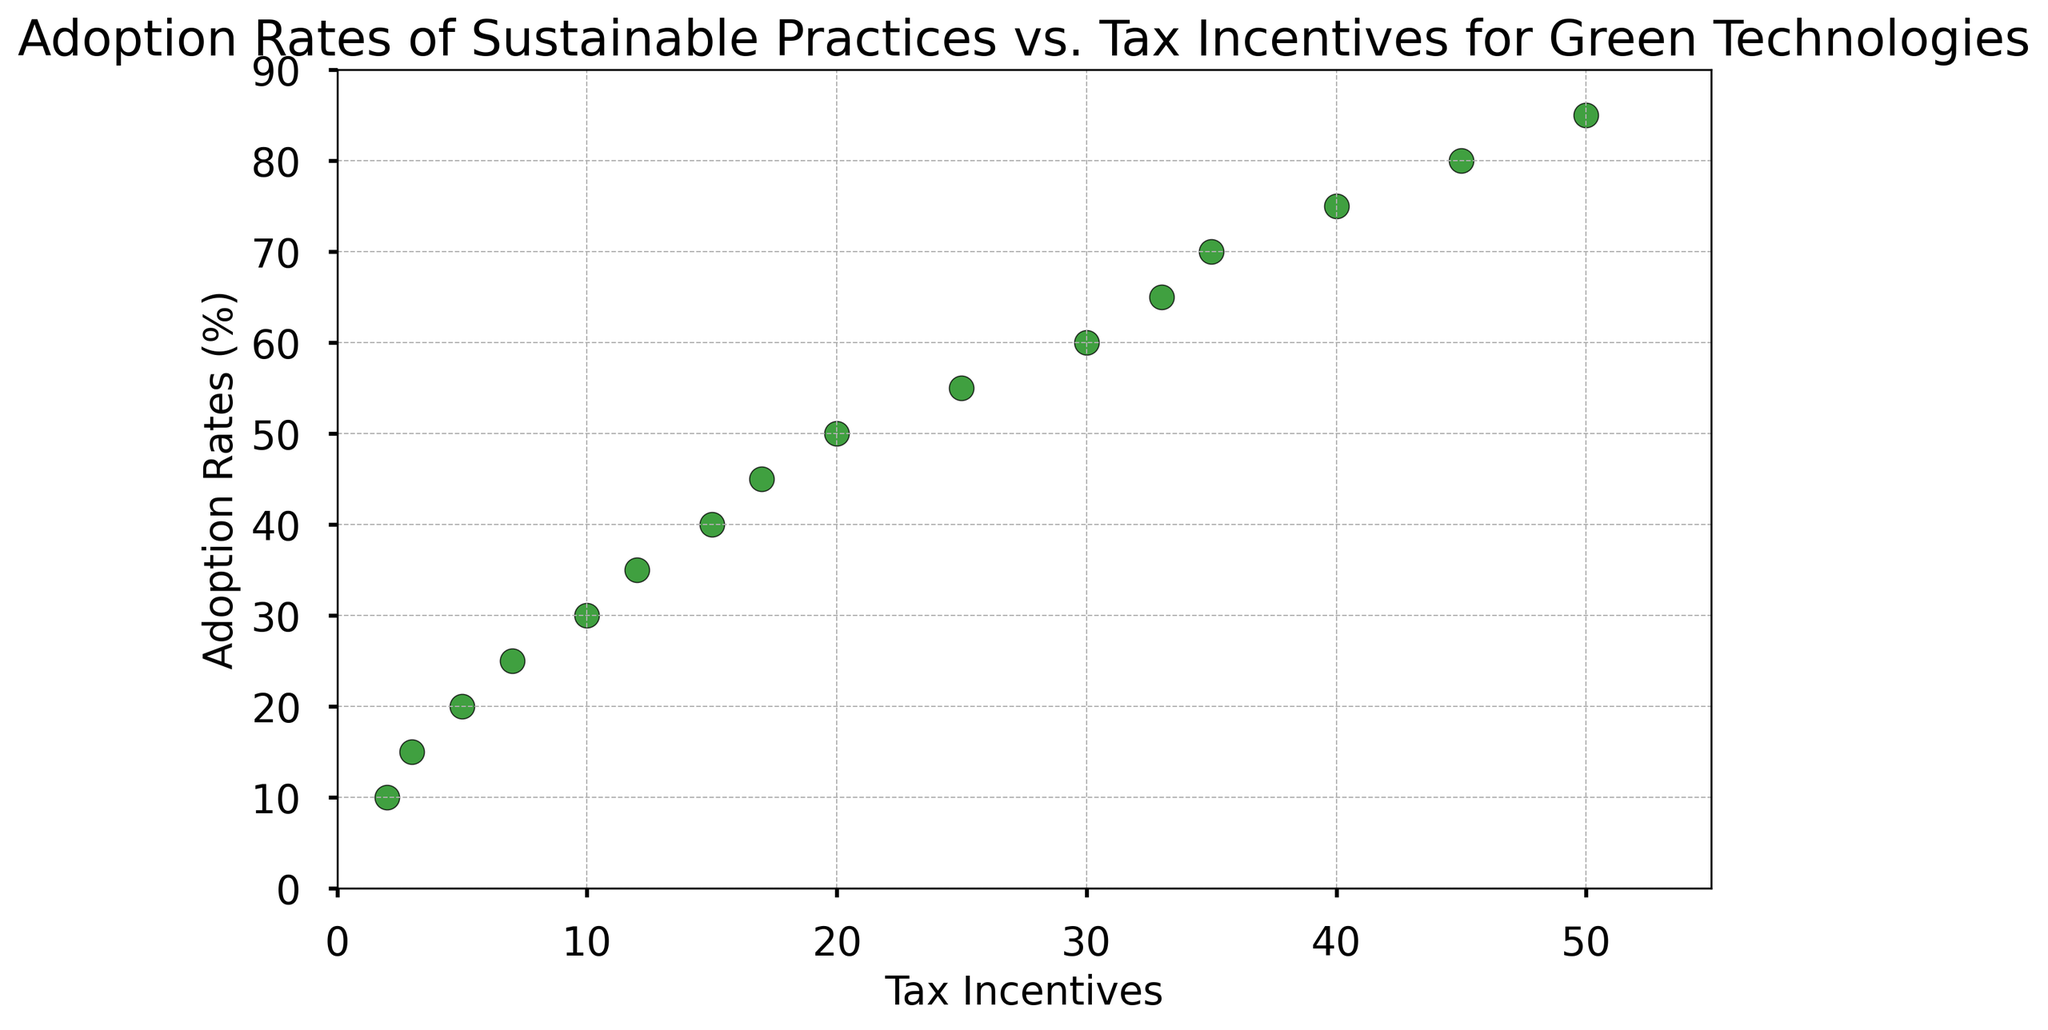What is the adoption rate of sustainable practices when tax incentives are at their maximum value? The maximum value of tax incentives in the plot is 50. At this point, the corresponding adoption rate of sustainable practices is visible on the y-axis.
Answer: 85% What is the range of tax incentives shown in the plot? The range of tax incentives can be determined by looking at the x-axis, starting from the minimum value to the maximum value.
Answer: 2 to 50 Which point has the highest adoption rate of sustainable practices, and what is the corresponding tax incentive value? By looking at the point with the highest y-value (indicating adoption rate) in the scatter plot, the corresponding x-value (tax incentive) can be found.
Answer: 85% adoption rate with a tax incentive of 50 Is there a noticeable trend between tax incentives and adoption rates of sustainable practices? Visually, the scatter plot shows that as tax incentives increase along the x-axis, the adoption rates also increase along the y-axis, indicating a positive correlation.
Answer: Yes, a positive correlation What is the adoption rate when tax incentives are 20? Find the data point located at x = 20 on the scatter plot and observe the corresponding y-value.
Answer: 50% Which two tax incentive values have the same adoption rate of sustainable practices? Look for points on the plot that align horizontally at the same y-value. Check the x-values of these points.
Answer: 40 and 50 both have an adoption rate of 70% What is the difference in adoption rates between the maximum and minimum tax incentives? Subtract the adoption rate at the minimum tax incentive (10%) from the adoption rate at the maximum tax incentive (85%).
Answer: 75% How many data points show an adoption rate higher than 60%? Count the number of points in the scatter plot where the y-value is greater than 60%.
Answer: 10 What tax incentive value correlates with the adoption rate of 40%? Locate the point on the scatter plot with a y-value of 40%, and determine the corresponding x-value.
Answer: 17 What is the average adoption rate for tax incentives of 30 and 35? Find the adoption rates for tax incentives of 30 (40%) and 35 (50%), sum them (20 + 35), and then divide by 2 to calculate the average.
Answer: 55 